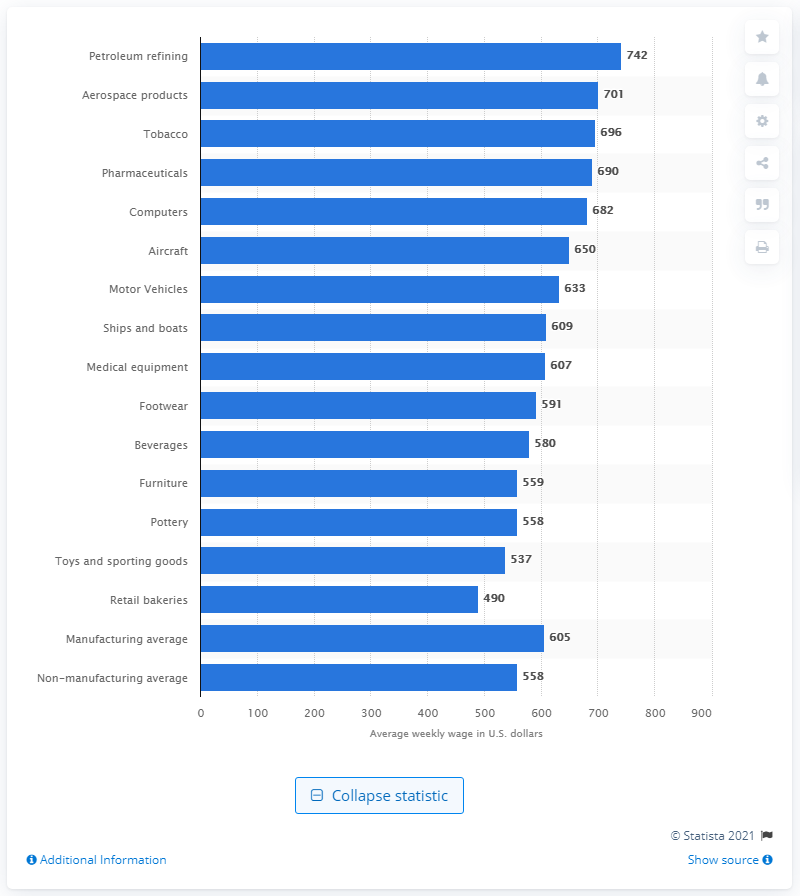Point out several critical features in this image. The average wage for computer manufacturing workers between 2008 and 2010 was approximately 682. 